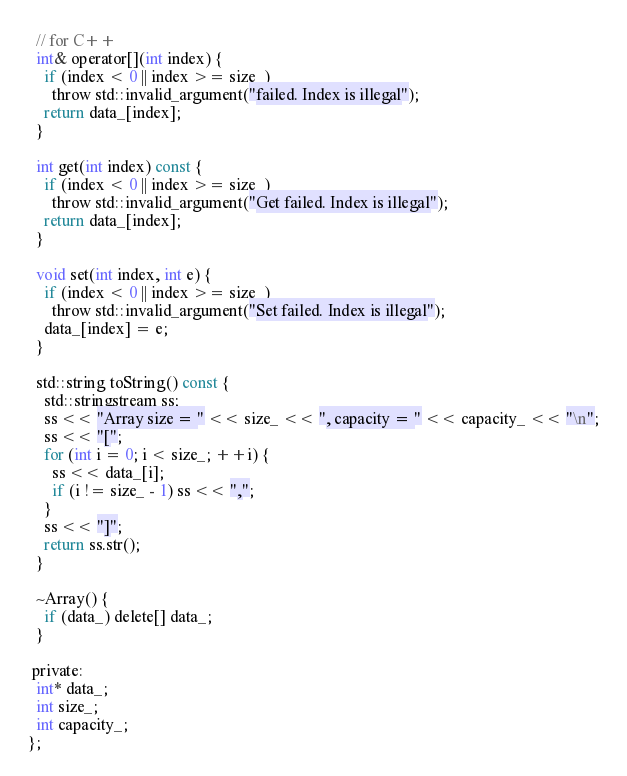<code> <loc_0><loc_0><loc_500><loc_500><_C_>  // for C++
  int& operator[](int index) {
    if (index < 0 || index >= size_)
      throw std::invalid_argument("failed. Index is illegal");
    return data_[index];
  }

  int get(int index) const {
    if (index < 0 || index >= size_)
      throw std::invalid_argument("Get failed. Index is illegal");
    return data_[index];
  }

  void set(int index, int e) {
    if (index < 0 || index >= size_)
      throw std::invalid_argument("Set failed. Index is illegal");
    data_[index] = e;
  }

  std::string toString() const {
    std::stringstream ss;
    ss << "Array size = " << size_ << ", capacity = " << capacity_ << "\n";
    ss << "[";
    for (int i = 0; i < size_; ++i) {
      ss << data_[i];
      if (i != size_ - 1) ss << ",";
    }
    ss << "]";
    return ss.str();
  }

  ~Array() {
    if (data_) delete[] data_;
  }

 private:
  int* data_;
  int size_;
  int capacity_;
};</code> 